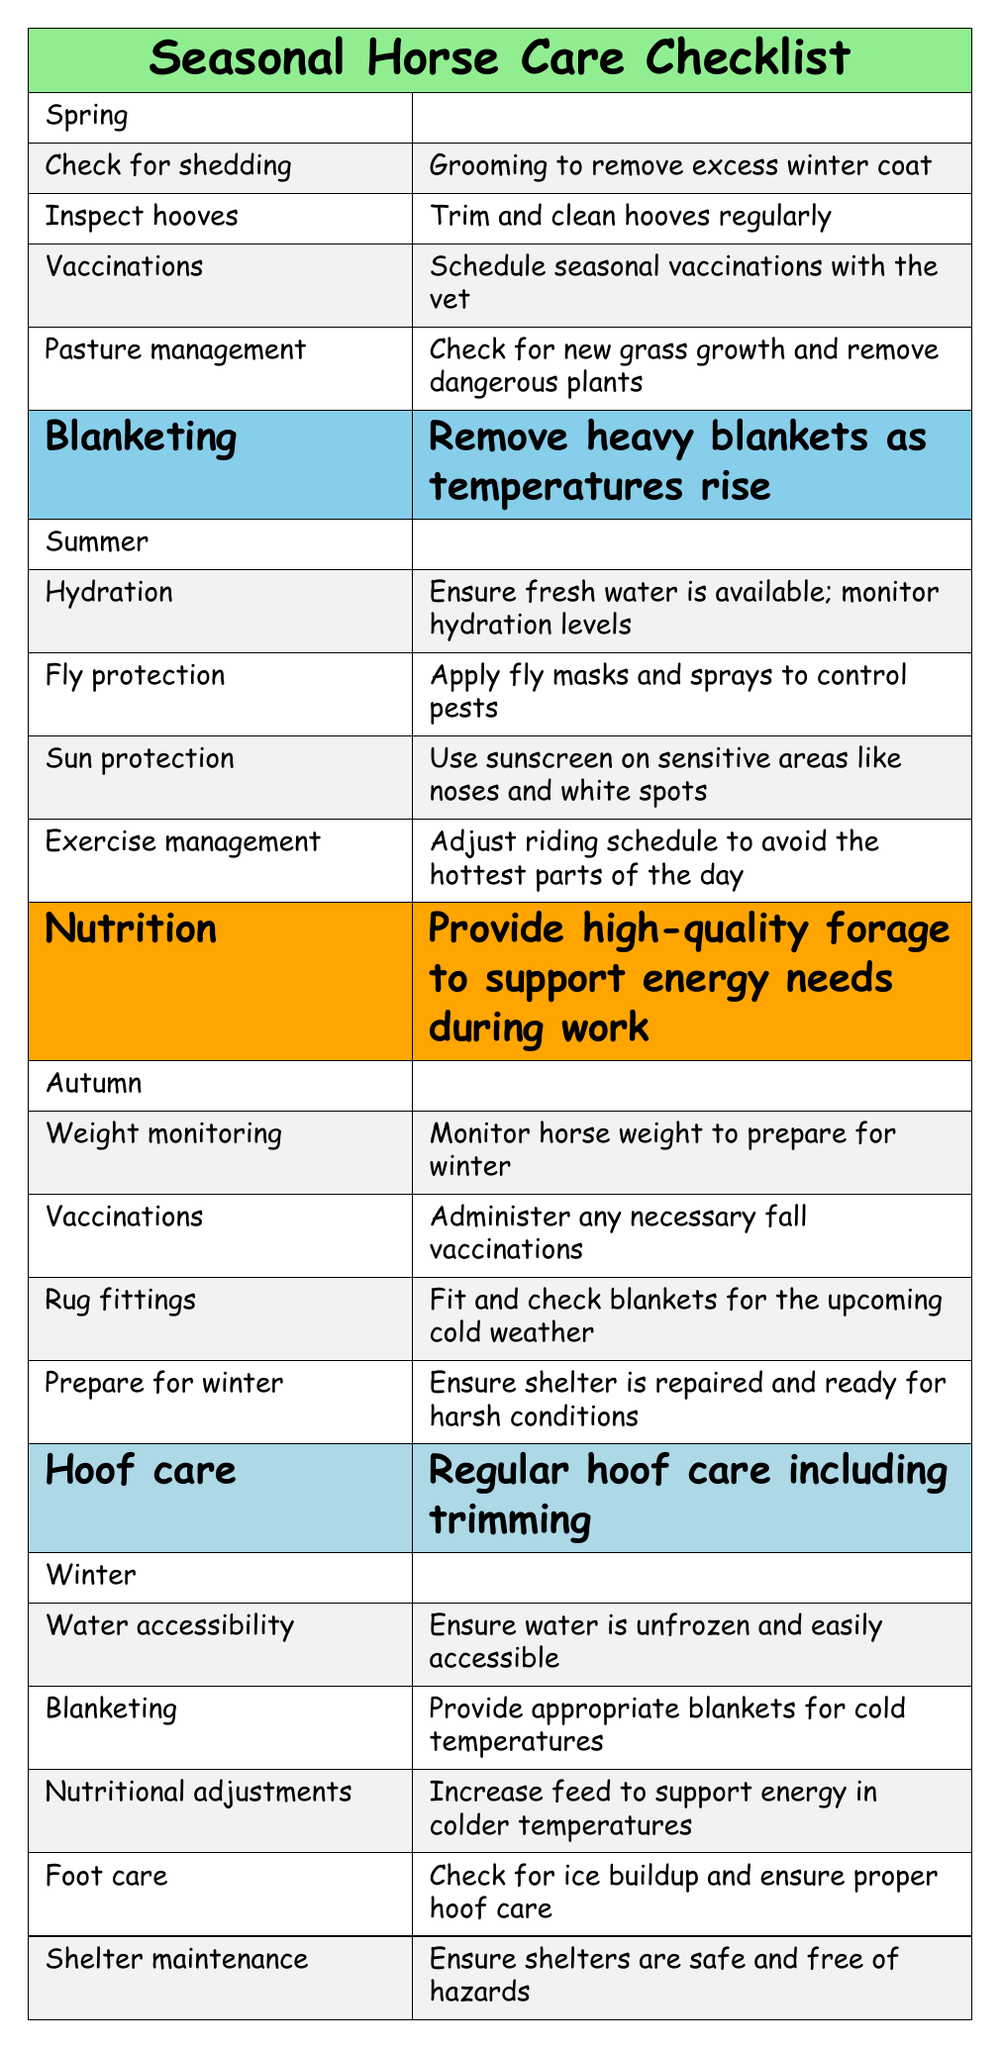What tasks are recommended for Spring horse care? The table lists five tasks under Spring activities: check for shedding, inspect hooves, schedule vaccinations, manage pasture, and remove heavy blankets.
Answer: Check for shedding, inspect hooves, schedule vaccinations, manage pasture, remove heavy blankets How many activities are there for Summer horse care? The table shows five activities listed under Summer: hydration, fly protection, sun protection, exercise management, and nutrition.
Answer: 5 Is "nutritional adjustments" a task in Autumn horse care? The table indicates that "nutritional adjustments" is not listed under Autumn, as it is in Winter instead.
Answer: No What task involves "sunscreen" application? "Sun protection" refers to the task that involves applying sunscreen on sensitive areas.
Answer: Sun protection Which season has the activity "weight monitoring"? The "weight monitoring" task is listed under Autumn activities for horse care.
Answer: Autumn What are two activities listed for Winter horse care? The table includes five activities under Winter, and two examples are ensuring water accessibility and providing appropriate blankets.
Answer: Ensure water accessibility, provide appropriate blankets What is the main purpose of "fly protection" in Summer? "Fly protection" is about applying masks and sprays to control pests and keep horses comfortable during hot weather.
Answer: To control pests How many total activities are listed across all seasons? There are five activities in Spring, five in Summer, five in Autumn, and five in Winter, totaling 20 activities (5+5+5+5=20).
Answer: 20 Which season's tasks include "hydration" and "nutrition"? "Hydration" and "nutrition" are both included in the Summer tasks for horse care.
Answer: Summer Are there any tasks related to "shelter maintenance"? The table shows that "shelter maintenance" is a task listed under Winter care.
Answer: Yes What task needs to be done before winter in Autumn? A task listed in Autumn is "prepare for winter," which involves ensuring shelter is repaired for harsh conditions.
Answer: Prepare for winter 